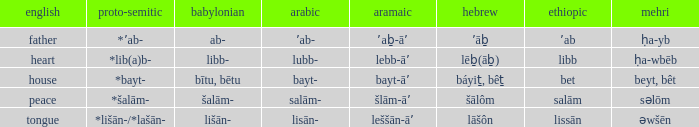If the aramaic is šlām-āʼ, what is the english? Peace. I'm looking to parse the entire table for insights. Could you assist me with that? {'header': ['english', 'proto-semitic', 'babylonian', 'arabic', 'aramaic', 'hebrew', 'ethiopic', 'mehri'], 'rows': [['father', '*ʼab-', 'ab-', 'ʼab-', 'ʼaḇ-āʼ', 'ʼāḇ', 'ʼab', 'ḥa-yb'], ['heart', '*lib(a)b-', 'libb-', 'lubb-', 'lebb-āʼ', 'lēḇ(āḇ)', 'libb', 'ḥa-wbēb'], ['house', '*bayt-', 'bītu, bētu', 'bayt-', 'bayt-āʼ', 'báyiṯ, bêṯ', 'bet', 'beyt, bêt'], ['peace', '*šalām-', 'šalām-', 'salām-', 'šlām-āʼ', 'šālôm', 'salām', 'səlōm'], ['tongue', '*lišān-/*lašān-', 'lišān-', 'lisān-', 'leššān-āʼ', 'lāšôn', 'lissān', 'əwšēn']]} 